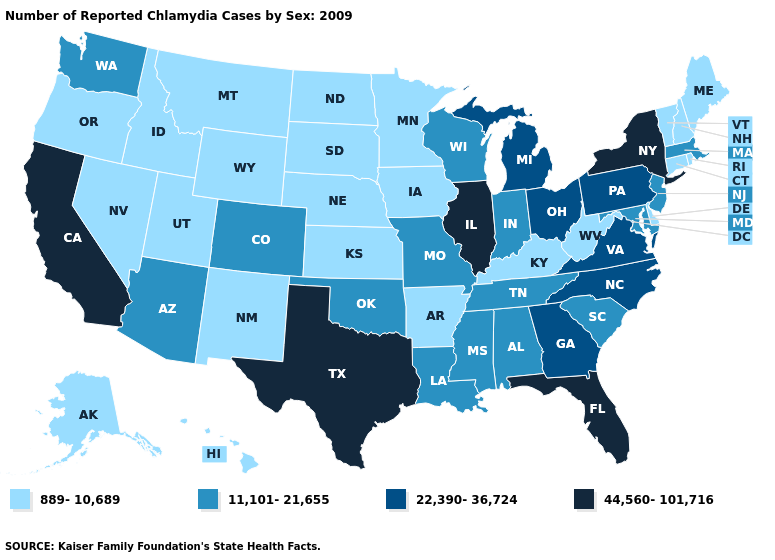Among the states that border Iowa , does Missouri have the lowest value?
Be succinct. No. Name the states that have a value in the range 22,390-36,724?
Quick response, please. Georgia, Michigan, North Carolina, Ohio, Pennsylvania, Virginia. Which states have the lowest value in the Northeast?
Concise answer only. Connecticut, Maine, New Hampshire, Rhode Island, Vermont. Does the first symbol in the legend represent the smallest category?
Quick response, please. Yes. Among the states that border Texas , which have the highest value?
Be succinct. Louisiana, Oklahoma. Is the legend a continuous bar?
Short answer required. No. Name the states that have a value in the range 22,390-36,724?
Give a very brief answer. Georgia, Michigan, North Carolina, Ohio, Pennsylvania, Virginia. What is the value of Illinois?
Quick response, please. 44,560-101,716. What is the value of Arizona?
Be succinct. 11,101-21,655. Name the states that have a value in the range 22,390-36,724?
Give a very brief answer. Georgia, Michigan, North Carolina, Ohio, Pennsylvania, Virginia. What is the lowest value in the South?
Answer briefly. 889-10,689. What is the lowest value in states that border Georgia?
Give a very brief answer. 11,101-21,655. What is the value of Alabama?
Give a very brief answer. 11,101-21,655. Does Utah have the highest value in the USA?
Answer briefly. No. 